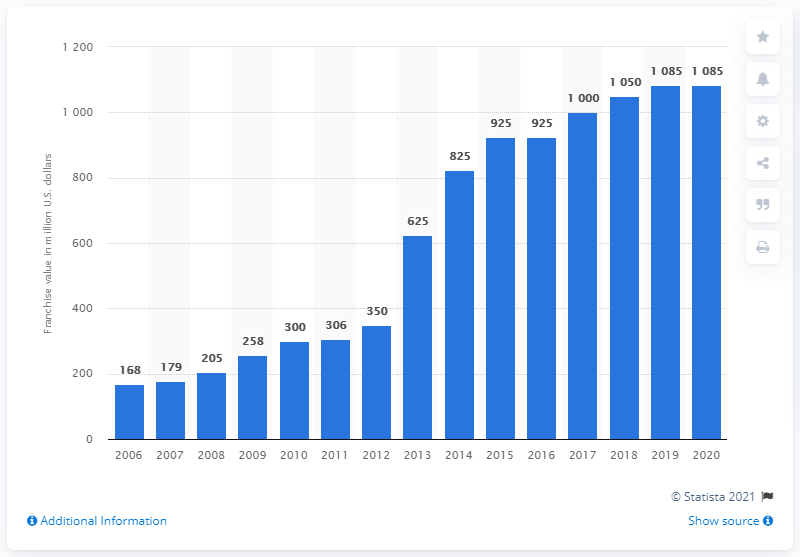Identify some key points in this picture. In 2020, the value of the Chicago Blackhawks franchise was approximately 1085 dollars. 